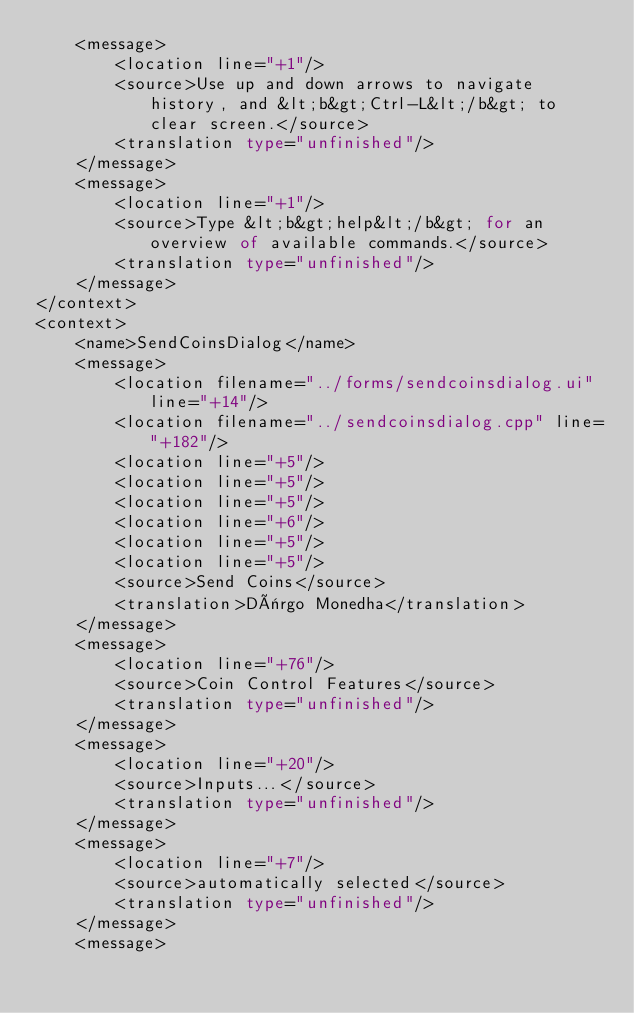<code> <loc_0><loc_0><loc_500><loc_500><_TypeScript_>    <message>
        <location line="+1"/>
        <source>Use up and down arrows to navigate history, and &lt;b&gt;Ctrl-L&lt;/b&gt; to clear screen.</source>
        <translation type="unfinished"/>
    </message>
    <message>
        <location line="+1"/>
        <source>Type &lt;b&gt;help&lt;/b&gt; for an overview of available commands.</source>
        <translation type="unfinished"/>
    </message>
</context>
<context>
    <name>SendCoinsDialog</name>
    <message>
        <location filename="../forms/sendcoinsdialog.ui" line="+14"/>
        <location filename="../sendcoinsdialog.cpp" line="+182"/>
        <location line="+5"/>
        <location line="+5"/>
        <location line="+5"/>
        <location line="+6"/>
        <location line="+5"/>
        <location line="+5"/>
        <source>Send Coins</source>
        <translation>Dërgo Monedha</translation>
    </message>
    <message>
        <location line="+76"/>
        <source>Coin Control Features</source>
        <translation type="unfinished"/>
    </message>
    <message>
        <location line="+20"/>
        <source>Inputs...</source>
        <translation type="unfinished"/>
    </message>
    <message>
        <location line="+7"/>
        <source>automatically selected</source>
        <translation type="unfinished"/>
    </message>
    <message></code> 